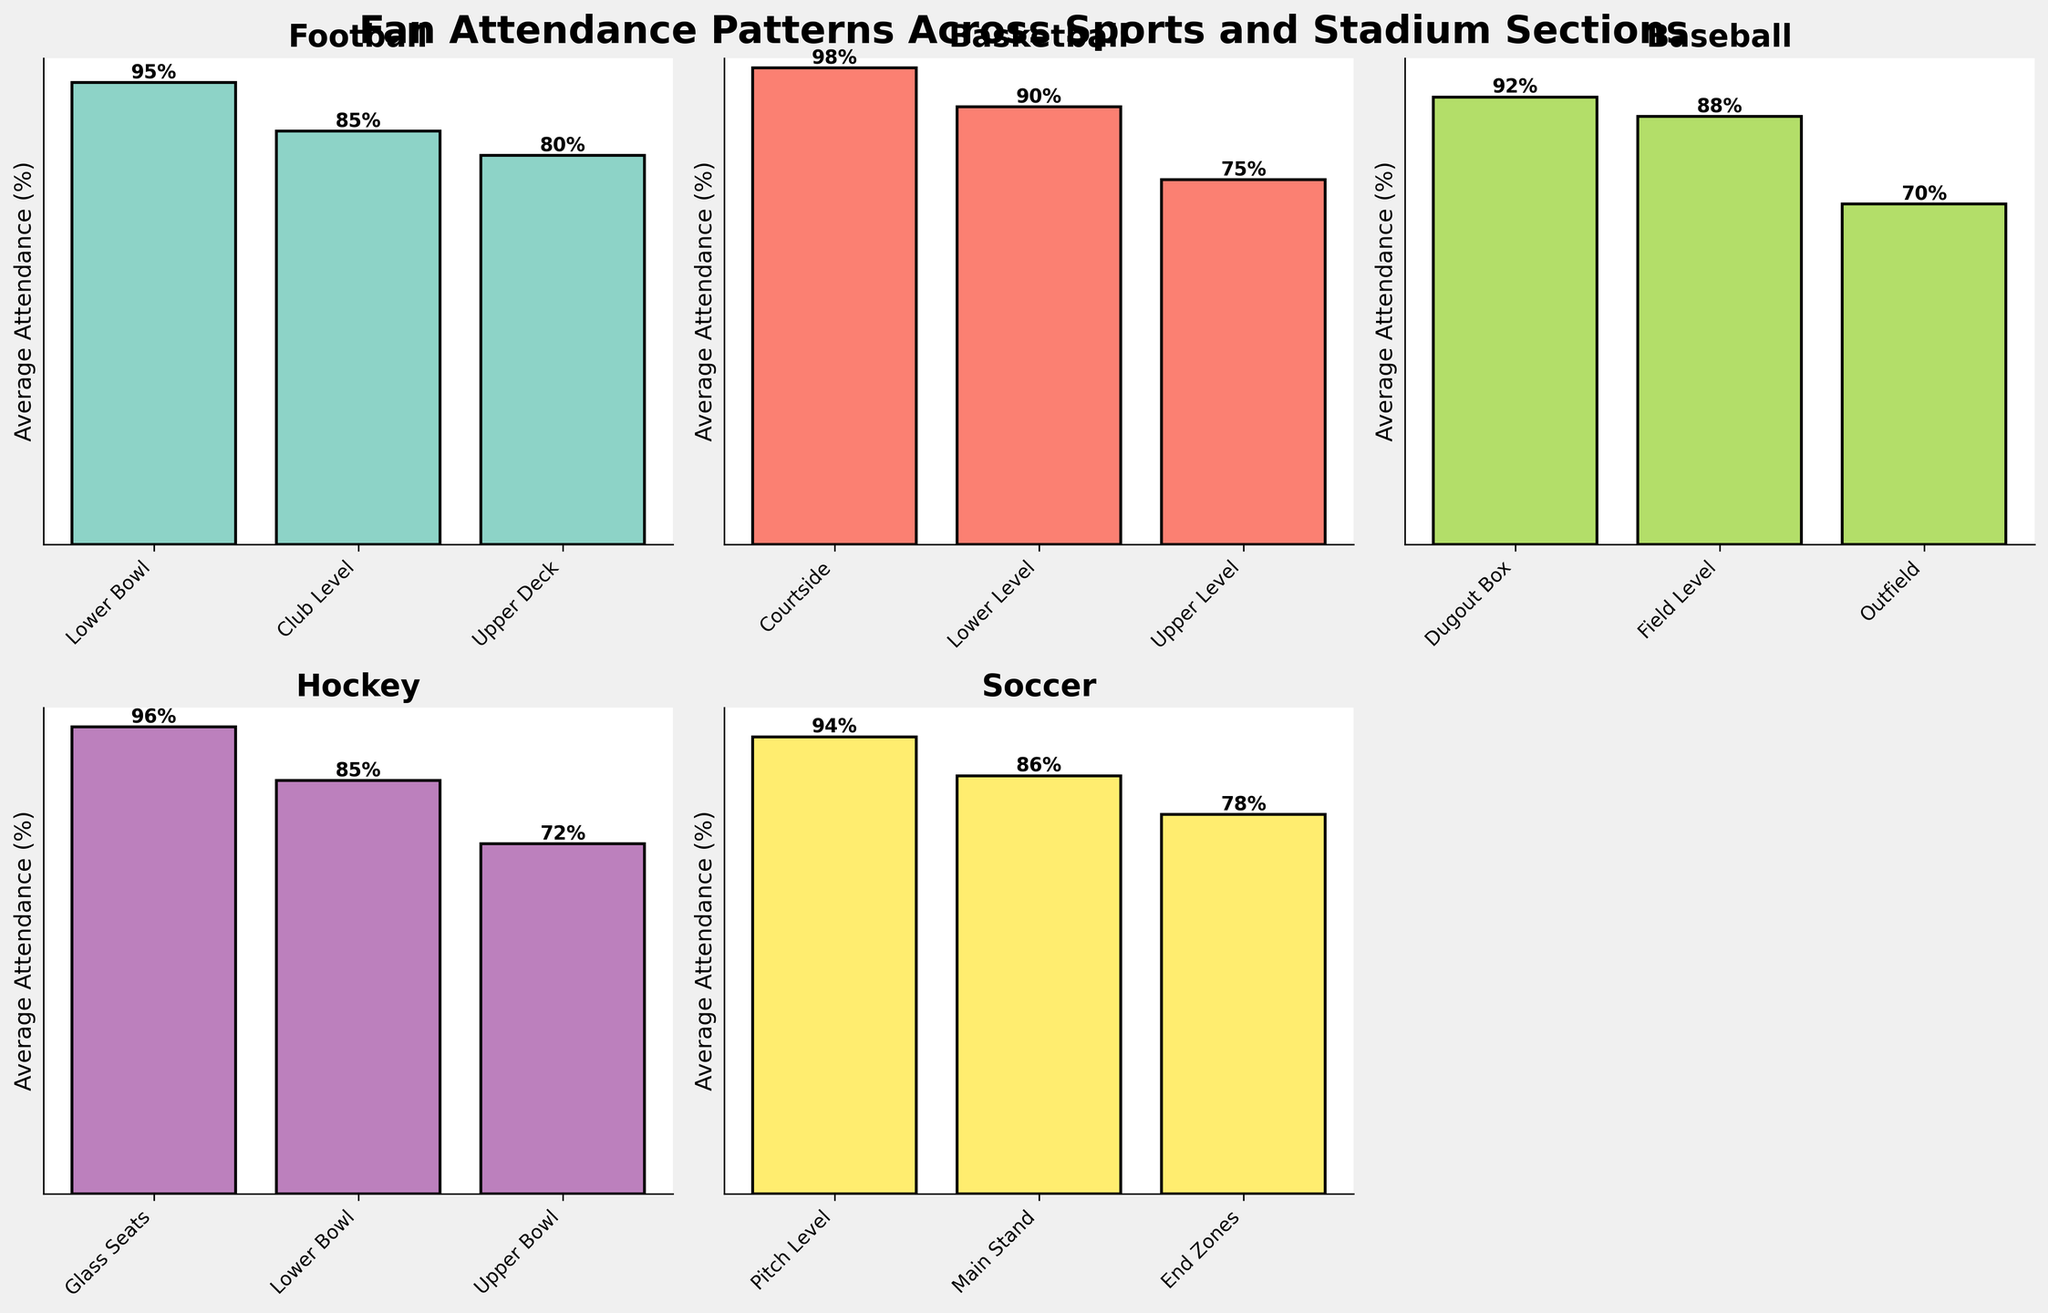What sport has the highest average attendance in its best section? Look at the bar for each sport section and identify the bar with the highest value. It's Courtside in Basketball with 98%.
Answer: Basketball What's the average attendance in the Upper Deck section for Football and the Upper Level section for Basketball? Look at the Upper Deck section for Football (80%) and the Upper Level section for Basketball (75%). Calculate the average: (80 + 75) / 2 = 77.5
Answer: 77.5 Which sport section has the lowest attendance, and what is the value? Scan all sections on the plots to find the lowest bar. It's the Outfield section in Baseball with 70%.
Answer: Outfield in Baseball Are there any sports where all sections have an average attendance of at least 85%? Check every section for each sport. Soccer has Pitch Level (94%), Main Stand (86%), and End Zones (78%), where the End Zones section is below 85%. No sport meets the criteria.
Answer: No How does the attendance of Club Level in Football compare to Main Stand in Soccer? Look at the Club Level in Football (85%) and Main Stand in Soccer (86%). Compare the values; Main Stand in Soccer has 1% more attendance.
Answer: Main Stand in Soccer is higher by 1% What's the range of average attendance values for Baseball? Identify the highest and lowest values in Baseball sections: Dugout Box (92%) and Outfield (70%). Calculate the range: 92 - 70 = 22.
Answer: 22 How many sports have their highest average attendance at or above 95%? Identify the top attendance for each sport: Football (Lower Bowl 95%), Basketball (Courtside 98%), Baseball (Dugout Box 92%), Hockey (Glass Seats 96%), Soccer (Pitch Level 94%). Count those with ≥ 95%: Football, Basketball, Hockey.
Answer: 3 Which sport has the most consistent average attendance across all sections? Determine the variance in attendance for each sport. Soccer has Pitch Level (94%), Main Stand (86%), and End Zones (78%). Calculate range: 94 - 78 = 16. Compare to ranges for Football (15), Basketball (23), Baseball (22), Hockey (24).
Answer: Football 